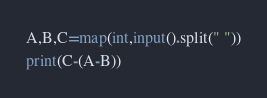<code> <loc_0><loc_0><loc_500><loc_500><_Python_>A,B,C=map(int,input().split(" "))
print(C-(A-B))</code> 